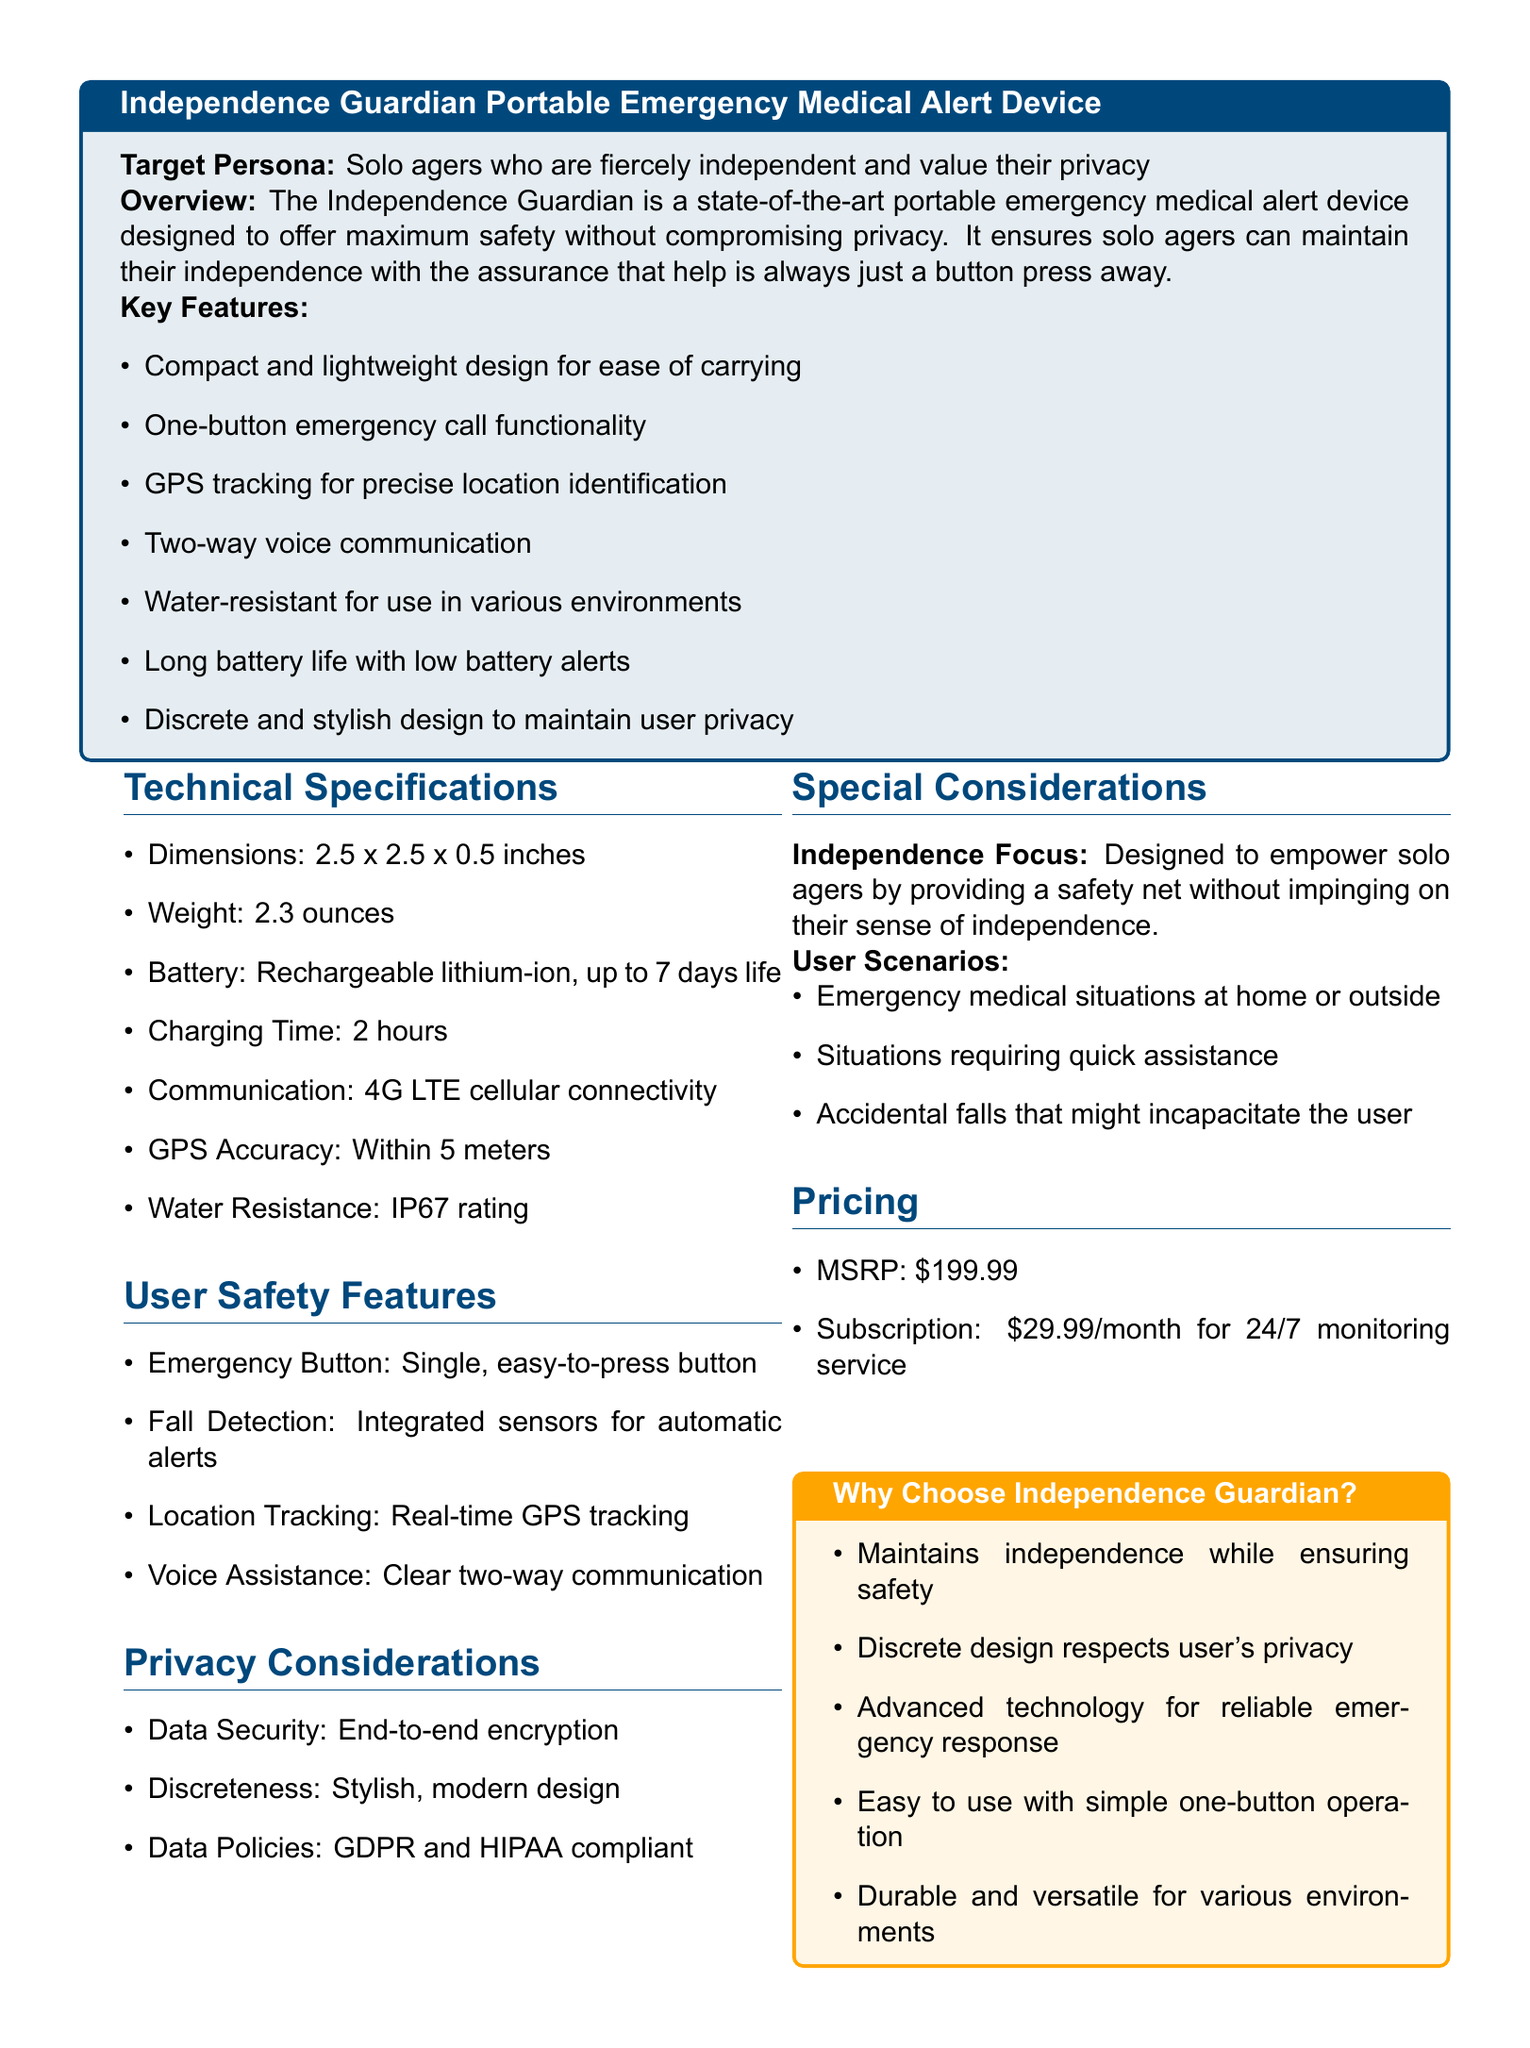What is the weight of the device? The weight of the device is stated in the technical specifications section.
Answer: 2.3 ounces What is the communication technology used? The communication type is specified under technical specifications.
Answer: 4G LTE cellular connectivity What is the battery life of the device? Battery life details are listed in the technical specifications.
Answer: up to 7 days life What features ensure user privacy? Privacy-related features are mentioned in the privacy considerations section.
Answer: End-to-end encryption What is the MSRP of the device? The pricing section provides the manufacturer's suggested retail price.
Answer: $199.99 How is the device designed for independence? This is explained in the special considerations section highlighting its purpose.
Answer: Empower solo agers What is the primary function of the emergency button? The main function of the emergency button is outlined in the user safety features section.
Answer: Single, easy-to-press button How is the device water-resistant? The level of water resistance is described in the technical specifications section.
Answer: IP67 rating What is the subscription cost for monitoring service? Subscription pricing is stated clearly in the pricing section of the document.
Answer: $29.99/month 